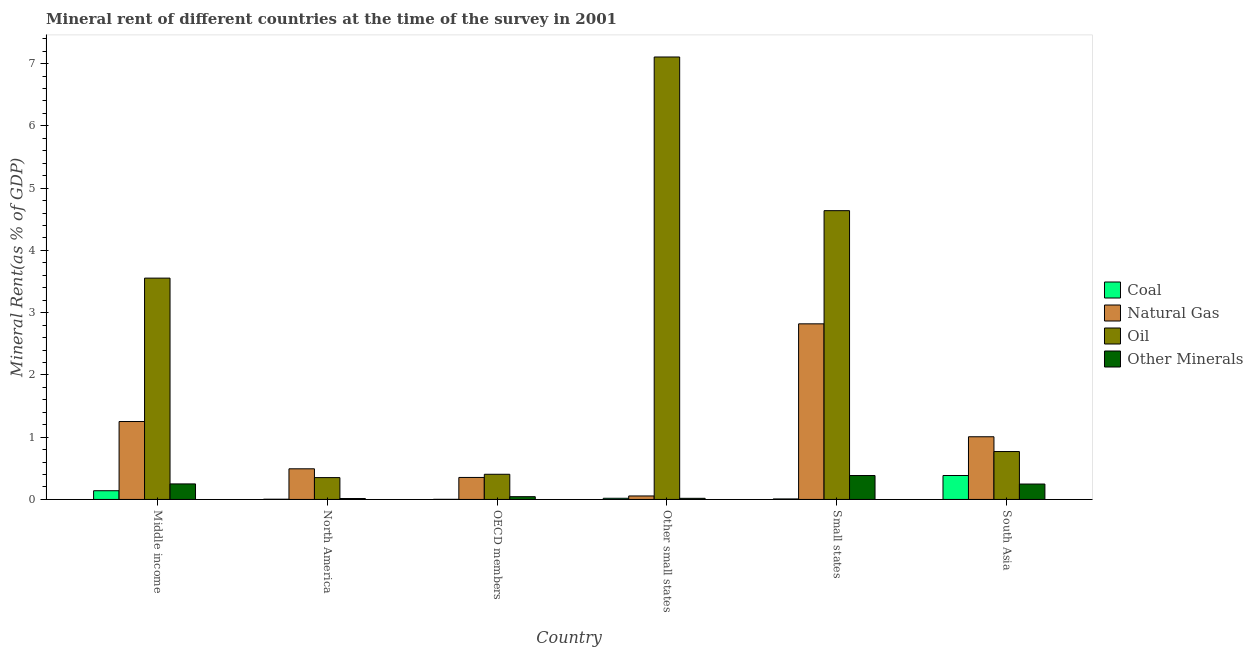How many different coloured bars are there?
Offer a very short reply. 4. How many groups of bars are there?
Ensure brevity in your answer.  6. How many bars are there on the 4th tick from the left?
Offer a very short reply. 4. What is the label of the 4th group of bars from the left?
Ensure brevity in your answer.  Other small states. In how many cases, is the number of bars for a given country not equal to the number of legend labels?
Your response must be concise. 0. What is the oil rent in North America?
Offer a terse response. 0.35. Across all countries, what is the maximum coal rent?
Offer a terse response. 0.38. Across all countries, what is the minimum coal rent?
Your answer should be very brief. 0. In which country was the  rent of other minerals maximum?
Make the answer very short. Small states. In which country was the coal rent minimum?
Provide a short and direct response. OECD members. What is the total coal rent in the graph?
Make the answer very short. 0.56. What is the difference between the  rent of other minerals in North America and that in South Asia?
Provide a short and direct response. -0.23. What is the difference between the natural gas rent in Middle income and the coal rent in North America?
Offer a terse response. 1.25. What is the average  rent of other minerals per country?
Ensure brevity in your answer.  0.16. What is the difference between the oil rent and natural gas rent in Small states?
Your response must be concise. 1.82. In how many countries, is the natural gas rent greater than 5.4 %?
Provide a succinct answer. 0. What is the ratio of the oil rent in Middle income to that in South Asia?
Offer a terse response. 4.62. Is the oil rent in Middle income less than that in Small states?
Provide a short and direct response. Yes. Is the difference between the  rent of other minerals in Middle income and South Asia greater than the difference between the oil rent in Middle income and South Asia?
Your response must be concise. No. What is the difference between the highest and the second highest coal rent?
Offer a terse response. 0.24. What is the difference between the highest and the lowest  rent of other minerals?
Keep it short and to the point. 0.37. What does the 1st bar from the left in OECD members represents?
Provide a short and direct response. Coal. What does the 4th bar from the right in OECD members represents?
Your answer should be compact. Coal. How many bars are there?
Make the answer very short. 24. Are all the bars in the graph horizontal?
Ensure brevity in your answer.  No. Are the values on the major ticks of Y-axis written in scientific E-notation?
Give a very brief answer. No. Does the graph contain grids?
Offer a very short reply. No. Where does the legend appear in the graph?
Provide a succinct answer. Center right. What is the title of the graph?
Give a very brief answer. Mineral rent of different countries at the time of the survey in 2001. Does "Primary" appear as one of the legend labels in the graph?
Your response must be concise. No. What is the label or title of the Y-axis?
Ensure brevity in your answer.  Mineral Rent(as % of GDP). What is the Mineral Rent(as % of GDP) of Coal in Middle income?
Your answer should be compact. 0.14. What is the Mineral Rent(as % of GDP) in Natural Gas in Middle income?
Your response must be concise. 1.25. What is the Mineral Rent(as % of GDP) in Oil in Middle income?
Keep it short and to the point. 3.55. What is the Mineral Rent(as % of GDP) in Other Minerals in Middle income?
Give a very brief answer. 0.25. What is the Mineral Rent(as % of GDP) in Coal in North America?
Offer a very short reply. 0. What is the Mineral Rent(as % of GDP) of Natural Gas in North America?
Make the answer very short. 0.49. What is the Mineral Rent(as % of GDP) of Oil in North America?
Your answer should be very brief. 0.35. What is the Mineral Rent(as % of GDP) in Other Minerals in North America?
Provide a short and direct response. 0.01. What is the Mineral Rent(as % of GDP) of Coal in OECD members?
Ensure brevity in your answer.  0. What is the Mineral Rent(as % of GDP) in Natural Gas in OECD members?
Provide a succinct answer. 0.35. What is the Mineral Rent(as % of GDP) in Oil in OECD members?
Your answer should be very brief. 0.4. What is the Mineral Rent(as % of GDP) in Other Minerals in OECD members?
Keep it short and to the point. 0.04. What is the Mineral Rent(as % of GDP) in Coal in Other small states?
Your answer should be compact. 0.02. What is the Mineral Rent(as % of GDP) in Natural Gas in Other small states?
Your answer should be compact. 0.06. What is the Mineral Rent(as % of GDP) in Oil in Other small states?
Your answer should be compact. 7.11. What is the Mineral Rent(as % of GDP) in Other Minerals in Other small states?
Your answer should be compact. 0.02. What is the Mineral Rent(as % of GDP) of Coal in Small states?
Give a very brief answer. 0.01. What is the Mineral Rent(as % of GDP) of Natural Gas in Small states?
Offer a very short reply. 2.82. What is the Mineral Rent(as % of GDP) of Oil in Small states?
Offer a terse response. 4.64. What is the Mineral Rent(as % of GDP) of Other Minerals in Small states?
Your answer should be very brief. 0.38. What is the Mineral Rent(as % of GDP) in Coal in South Asia?
Ensure brevity in your answer.  0.38. What is the Mineral Rent(as % of GDP) in Natural Gas in South Asia?
Provide a short and direct response. 1.01. What is the Mineral Rent(as % of GDP) in Oil in South Asia?
Give a very brief answer. 0.77. What is the Mineral Rent(as % of GDP) of Other Minerals in South Asia?
Your answer should be compact. 0.25. Across all countries, what is the maximum Mineral Rent(as % of GDP) of Coal?
Give a very brief answer. 0.38. Across all countries, what is the maximum Mineral Rent(as % of GDP) in Natural Gas?
Provide a succinct answer. 2.82. Across all countries, what is the maximum Mineral Rent(as % of GDP) of Oil?
Provide a short and direct response. 7.11. Across all countries, what is the maximum Mineral Rent(as % of GDP) of Other Minerals?
Ensure brevity in your answer.  0.38. Across all countries, what is the minimum Mineral Rent(as % of GDP) in Coal?
Offer a terse response. 0. Across all countries, what is the minimum Mineral Rent(as % of GDP) of Natural Gas?
Keep it short and to the point. 0.06. Across all countries, what is the minimum Mineral Rent(as % of GDP) in Oil?
Your answer should be very brief. 0.35. Across all countries, what is the minimum Mineral Rent(as % of GDP) in Other Minerals?
Your answer should be very brief. 0.01. What is the total Mineral Rent(as % of GDP) in Coal in the graph?
Offer a terse response. 0.56. What is the total Mineral Rent(as % of GDP) in Natural Gas in the graph?
Offer a terse response. 5.98. What is the total Mineral Rent(as % of GDP) in Oil in the graph?
Keep it short and to the point. 16.82. What is the total Mineral Rent(as % of GDP) of Other Minerals in the graph?
Give a very brief answer. 0.96. What is the difference between the Mineral Rent(as % of GDP) of Coal in Middle income and that in North America?
Make the answer very short. 0.14. What is the difference between the Mineral Rent(as % of GDP) of Natural Gas in Middle income and that in North America?
Provide a succinct answer. 0.76. What is the difference between the Mineral Rent(as % of GDP) in Oil in Middle income and that in North America?
Keep it short and to the point. 3.2. What is the difference between the Mineral Rent(as % of GDP) of Other Minerals in Middle income and that in North America?
Your response must be concise. 0.23. What is the difference between the Mineral Rent(as % of GDP) of Coal in Middle income and that in OECD members?
Keep it short and to the point. 0.14. What is the difference between the Mineral Rent(as % of GDP) in Natural Gas in Middle income and that in OECD members?
Provide a short and direct response. 0.9. What is the difference between the Mineral Rent(as % of GDP) in Oil in Middle income and that in OECD members?
Your response must be concise. 3.15. What is the difference between the Mineral Rent(as % of GDP) of Other Minerals in Middle income and that in OECD members?
Keep it short and to the point. 0.21. What is the difference between the Mineral Rent(as % of GDP) of Coal in Middle income and that in Other small states?
Provide a short and direct response. 0.12. What is the difference between the Mineral Rent(as % of GDP) of Natural Gas in Middle income and that in Other small states?
Provide a succinct answer. 1.2. What is the difference between the Mineral Rent(as % of GDP) in Oil in Middle income and that in Other small states?
Provide a succinct answer. -3.55. What is the difference between the Mineral Rent(as % of GDP) in Other Minerals in Middle income and that in Other small states?
Make the answer very short. 0.23. What is the difference between the Mineral Rent(as % of GDP) of Coal in Middle income and that in Small states?
Provide a short and direct response. 0.13. What is the difference between the Mineral Rent(as % of GDP) in Natural Gas in Middle income and that in Small states?
Keep it short and to the point. -1.57. What is the difference between the Mineral Rent(as % of GDP) of Oil in Middle income and that in Small states?
Ensure brevity in your answer.  -1.08. What is the difference between the Mineral Rent(as % of GDP) in Other Minerals in Middle income and that in Small states?
Ensure brevity in your answer.  -0.13. What is the difference between the Mineral Rent(as % of GDP) of Coal in Middle income and that in South Asia?
Ensure brevity in your answer.  -0.24. What is the difference between the Mineral Rent(as % of GDP) in Natural Gas in Middle income and that in South Asia?
Offer a very short reply. 0.24. What is the difference between the Mineral Rent(as % of GDP) of Oil in Middle income and that in South Asia?
Your answer should be compact. 2.79. What is the difference between the Mineral Rent(as % of GDP) in Other Minerals in Middle income and that in South Asia?
Your answer should be very brief. 0. What is the difference between the Mineral Rent(as % of GDP) of Coal in North America and that in OECD members?
Make the answer very short. 0. What is the difference between the Mineral Rent(as % of GDP) in Natural Gas in North America and that in OECD members?
Give a very brief answer. 0.14. What is the difference between the Mineral Rent(as % of GDP) of Oil in North America and that in OECD members?
Your answer should be compact. -0.05. What is the difference between the Mineral Rent(as % of GDP) of Other Minerals in North America and that in OECD members?
Your response must be concise. -0.03. What is the difference between the Mineral Rent(as % of GDP) in Coal in North America and that in Other small states?
Your answer should be compact. -0.02. What is the difference between the Mineral Rent(as % of GDP) of Natural Gas in North America and that in Other small states?
Provide a short and direct response. 0.44. What is the difference between the Mineral Rent(as % of GDP) in Oil in North America and that in Other small states?
Make the answer very short. -6.75. What is the difference between the Mineral Rent(as % of GDP) of Other Minerals in North America and that in Other small states?
Give a very brief answer. -0. What is the difference between the Mineral Rent(as % of GDP) in Coal in North America and that in Small states?
Provide a succinct answer. -0. What is the difference between the Mineral Rent(as % of GDP) in Natural Gas in North America and that in Small states?
Your answer should be very brief. -2.33. What is the difference between the Mineral Rent(as % of GDP) in Oil in North America and that in Small states?
Keep it short and to the point. -4.29. What is the difference between the Mineral Rent(as % of GDP) of Other Minerals in North America and that in Small states?
Your answer should be compact. -0.37. What is the difference between the Mineral Rent(as % of GDP) in Coal in North America and that in South Asia?
Provide a succinct answer. -0.38. What is the difference between the Mineral Rent(as % of GDP) of Natural Gas in North America and that in South Asia?
Your response must be concise. -0.51. What is the difference between the Mineral Rent(as % of GDP) in Oil in North America and that in South Asia?
Keep it short and to the point. -0.42. What is the difference between the Mineral Rent(as % of GDP) of Other Minerals in North America and that in South Asia?
Ensure brevity in your answer.  -0.23. What is the difference between the Mineral Rent(as % of GDP) of Coal in OECD members and that in Other small states?
Offer a terse response. -0.02. What is the difference between the Mineral Rent(as % of GDP) of Natural Gas in OECD members and that in Other small states?
Ensure brevity in your answer.  0.3. What is the difference between the Mineral Rent(as % of GDP) in Oil in OECD members and that in Other small states?
Give a very brief answer. -6.7. What is the difference between the Mineral Rent(as % of GDP) in Other Minerals in OECD members and that in Other small states?
Offer a very short reply. 0.03. What is the difference between the Mineral Rent(as % of GDP) in Coal in OECD members and that in Small states?
Provide a short and direct response. -0.01. What is the difference between the Mineral Rent(as % of GDP) in Natural Gas in OECD members and that in Small states?
Give a very brief answer. -2.47. What is the difference between the Mineral Rent(as % of GDP) of Oil in OECD members and that in Small states?
Provide a short and direct response. -4.23. What is the difference between the Mineral Rent(as % of GDP) in Other Minerals in OECD members and that in Small states?
Your answer should be compact. -0.34. What is the difference between the Mineral Rent(as % of GDP) of Coal in OECD members and that in South Asia?
Offer a terse response. -0.38. What is the difference between the Mineral Rent(as % of GDP) in Natural Gas in OECD members and that in South Asia?
Provide a succinct answer. -0.65. What is the difference between the Mineral Rent(as % of GDP) of Oil in OECD members and that in South Asia?
Offer a terse response. -0.37. What is the difference between the Mineral Rent(as % of GDP) of Other Minerals in OECD members and that in South Asia?
Ensure brevity in your answer.  -0.2. What is the difference between the Mineral Rent(as % of GDP) of Coal in Other small states and that in Small states?
Offer a terse response. 0.01. What is the difference between the Mineral Rent(as % of GDP) of Natural Gas in Other small states and that in Small states?
Ensure brevity in your answer.  -2.76. What is the difference between the Mineral Rent(as % of GDP) in Oil in Other small states and that in Small states?
Your answer should be very brief. 2.47. What is the difference between the Mineral Rent(as % of GDP) of Other Minerals in Other small states and that in Small states?
Provide a short and direct response. -0.37. What is the difference between the Mineral Rent(as % of GDP) of Coal in Other small states and that in South Asia?
Your response must be concise. -0.37. What is the difference between the Mineral Rent(as % of GDP) of Natural Gas in Other small states and that in South Asia?
Make the answer very short. -0.95. What is the difference between the Mineral Rent(as % of GDP) of Oil in Other small states and that in South Asia?
Make the answer very short. 6.34. What is the difference between the Mineral Rent(as % of GDP) in Other Minerals in Other small states and that in South Asia?
Offer a terse response. -0.23. What is the difference between the Mineral Rent(as % of GDP) in Coal in Small states and that in South Asia?
Provide a succinct answer. -0.38. What is the difference between the Mineral Rent(as % of GDP) in Natural Gas in Small states and that in South Asia?
Make the answer very short. 1.81. What is the difference between the Mineral Rent(as % of GDP) of Oil in Small states and that in South Asia?
Offer a terse response. 3.87. What is the difference between the Mineral Rent(as % of GDP) of Other Minerals in Small states and that in South Asia?
Offer a very short reply. 0.14. What is the difference between the Mineral Rent(as % of GDP) in Coal in Middle income and the Mineral Rent(as % of GDP) in Natural Gas in North America?
Offer a very short reply. -0.35. What is the difference between the Mineral Rent(as % of GDP) of Coal in Middle income and the Mineral Rent(as % of GDP) of Oil in North America?
Provide a short and direct response. -0.21. What is the difference between the Mineral Rent(as % of GDP) of Coal in Middle income and the Mineral Rent(as % of GDP) of Other Minerals in North America?
Give a very brief answer. 0.13. What is the difference between the Mineral Rent(as % of GDP) in Natural Gas in Middle income and the Mineral Rent(as % of GDP) in Oil in North America?
Your response must be concise. 0.9. What is the difference between the Mineral Rent(as % of GDP) in Natural Gas in Middle income and the Mineral Rent(as % of GDP) in Other Minerals in North America?
Keep it short and to the point. 1.24. What is the difference between the Mineral Rent(as % of GDP) of Oil in Middle income and the Mineral Rent(as % of GDP) of Other Minerals in North America?
Offer a terse response. 3.54. What is the difference between the Mineral Rent(as % of GDP) in Coal in Middle income and the Mineral Rent(as % of GDP) in Natural Gas in OECD members?
Offer a terse response. -0.21. What is the difference between the Mineral Rent(as % of GDP) in Coal in Middle income and the Mineral Rent(as % of GDP) in Oil in OECD members?
Your answer should be compact. -0.26. What is the difference between the Mineral Rent(as % of GDP) in Coal in Middle income and the Mineral Rent(as % of GDP) in Other Minerals in OECD members?
Make the answer very short. 0.1. What is the difference between the Mineral Rent(as % of GDP) in Natural Gas in Middle income and the Mineral Rent(as % of GDP) in Oil in OECD members?
Your answer should be compact. 0.85. What is the difference between the Mineral Rent(as % of GDP) of Natural Gas in Middle income and the Mineral Rent(as % of GDP) of Other Minerals in OECD members?
Provide a succinct answer. 1.21. What is the difference between the Mineral Rent(as % of GDP) of Oil in Middle income and the Mineral Rent(as % of GDP) of Other Minerals in OECD members?
Your answer should be compact. 3.51. What is the difference between the Mineral Rent(as % of GDP) of Coal in Middle income and the Mineral Rent(as % of GDP) of Natural Gas in Other small states?
Offer a very short reply. 0.08. What is the difference between the Mineral Rent(as % of GDP) in Coal in Middle income and the Mineral Rent(as % of GDP) in Oil in Other small states?
Your response must be concise. -6.97. What is the difference between the Mineral Rent(as % of GDP) of Coal in Middle income and the Mineral Rent(as % of GDP) of Other Minerals in Other small states?
Provide a short and direct response. 0.12. What is the difference between the Mineral Rent(as % of GDP) in Natural Gas in Middle income and the Mineral Rent(as % of GDP) in Oil in Other small states?
Make the answer very short. -5.85. What is the difference between the Mineral Rent(as % of GDP) in Natural Gas in Middle income and the Mineral Rent(as % of GDP) in Other Minerals in Other small states?
Your response must be concise. 1.23. What is the difference between the Mineral Rent(as % of GDP) of Oil in Middle income and the Mineral Rent(as % of GDP) of Other Minerals in Other small states?
Keep it short and to the point. 3.54. What is the difference between the Mineral Rent(as % of GDP) of Coal in Middle income and the Mineral Rent(as % of GDP) of Natural Gas in Small states?
Keep it short and to the point. -2.68. What is the difference between the Mineral Rent(as % of GDP) of Coal in Middle income and the Mineral Rent(as % of GDP) of Oil in Small states?
Provide a short and direct response. -4.5. What is the difference between the Mineral Rent(as % of GDP) in Coal in Middle income and the Mineral Rent(as % of GDP) in Other Minerals in Small states?
Make the answer very short. -0.24. What is the difference between the Mineral Rent(as % of GDP) of Natural Gas in Middle income and the Mineral Rent(as % of GDP) of Oil in Small states?
Your answer should be very brief. -3.39. What is the difference between the Mineral Rent(as % of GDP) of Natural Gas in Middle income and the Mineral Rent(as % of GDP) of Other Minerals in Small states?
Provide a short and direct response. 0.87. What is the difference between the Mineral Rent(as % of GDP) of Oil in Middle income and the Mineral Rent(as % of GDP) of Other Minerals in Small states?
Keep it short and to the point. 3.17. What is the difference between the Mineral Rent(as % of GDP) of Coal in Middle income and the Mineral Rent(as % of GDP) of Natural Gas in South Asia?
Offer a terse response. -0.87. What is the difference between the Mineral Rent(as % of GDP) in Coal in Middle income and the Mineral Rent(as % of GDP) in Oil in South Asia?
Keep it short and to the point. -0.63. What is the difference between the Mineral Rent(as % of GDP) in Coal in Middle income and the Mineral Rent(as % of GDP) in Other Minerals in South Asia?
Your answer should be compact. -0.11. What is the difference between the Mineral Rent(as % of GDP) of Natural Gas in Middle income and the Mineral Rent(as % of GDP) of Oil in South Asia?
Give a very brief answer. 0.48. What is the difference between the Mineral Rent(as % of GDP) in Natural Gas in Middle income and the Mineral Rent(as % of GDP) in Other Minerals in South Asia?
Make the answer very short. 1. What is the difference between the Mineral Rent(as % of GDP) in Oil in Middle income and the Mineral Rent(as % of GDP) in Other Minerals in South Asia?
Your answer should be very brief. 3.31. What is the difference between the Mineral Rent(as % of GDP) in Coal in North America and the Mineral Rent(as % of GDP) in Natural Gas in OECD members?
Provide a short and direct response. -0.35. What is the difference between the Mineral Rent(as % of GDP) in Coal in North America and the Mineral Rent(as % of GDP) in Oil in OECD members?
Make the answer very short. -0.4. What is the difference between the Mineral Rent(as % of GDP) in Coal in North America and the Mineral Rent(as % of GDP) in Other Minerals in OECD members?
Your answer should be very brief. -0.04. What is the difference between the Mineral Rent(as % of GDP) of Natural Gas in North America and the Mineral Rent(as % of GDP) of Oil in OECD members?
Give a very brief answer. 0.09. What is the difference between the Mineral Rent(as % of GDP) in Natural Gas in North America and the Mineral Rent(as % of GDP) in Other Minerals in OECD members?
Give a very brief answer. 0.45. What is the difference between the Mineral Rent(as % of GDP) in Oil in North America and the Mineral Rent(as % of GDP) in Other Minerals in OECD members?
Offer a terse response. 0.31. What is the difference between the Mineral Rent(as % of GDP) in Coal in North America and the Mineral Rent(as % of GDP) in Natural Gas in Other small states?
Give a very brief answer. -0.05. What is the difference between the Mineral Rent(as % of GDP) of Coal in North America and the Mineral Rent(as % of GDP) of Oil in Other small states?
Ensure brevity in your answer.  -7.1. What is the difference between the Mineral Rent(as % of GDP) in Coal in North America and the Mineral Rent(as % of GDP) in Other Minerals in Other small states?
Keep it short and to the point. -0.01. What is the difference between the Mineral Rent(as % of GDP) in Natural Gas in North America and the Mineral Rent(as % of GDP) in Oil in Other small states?
Provide a succinct answer. -6.61. What is the difference between the Mineral Rent(as % of GDP) in Natural Gas in North America and the Mineral Rent(as % of GDP) in Other Minerals in Other small states?
Your answer should be very brief. 0.47. What is the difference between the Mineral Rent(as % of GDP) in Oil in North America and the Mineral Rent(as % of GDP) in Other Minerals in Other small states?
Offer a very short reply. 0.33. What is the difference between the Mineral Rent(as % of GDP) of Coal in North America and the Mineral Rent(as % of GDP) of Natural Gas in Small states?
Offer a very short reply. -2.82. What is the difference between the Mineral Rent(as % of GDP) in Coal in North America and the Mineral Rent(as % of GDP) in Oil in Small states?
Give a very brief answer. -4.63. What is the difference between the Mineral Rent(as % of GDP) of Coal in North America and the Mineral Rent(as % of GDP) of Other Minerals in Small states?
Offer a very short reply. -0.38. What is the difference between the Mineral Rent(as % of GDP) in Natural Gas in North America and the Mineral Rent(as % of GDP) in Oil in Small states?
Ensure brevity in your answer.  -4.15. What is the difference between the Mineral Rent(as % of GDP) in Natural Gas in North America and the Mineral Rent(as % of GDP) in Other Minerals in Small states?
Your answer should be compact. 0.11. What is the difference between the Mineral Rent(as % of GDP) in Oil in North America and the Mineral Rent(as % of GDP) in Other Minerals in Small states?
Offer a very short reply. -0.03. What is the difference between the Mineral Rent(as % of GDP) of Coal in North America and the Mineral Rent(as % of GDP) of Natural Gas in South Asia?
Provide a short and direct response. -1. What is the difference between the Mineral Rent(as % of GDP) of Coal in North America and the Mineral Rent(as % of GDP) of Oil in South Asia?
Make the answer very short. -0.77. What is the difference between the Mineral Rent(as % of GDP) in Coal in North America and the Mineral Rent(as % of GDP) in Other Minerals in South Asia?
Give a very brief answer. -0.24. What is the difference between the Mineral Rent(as % of GDP) in Natural Gas in North America and the Mineral Rent(as % of GDP) in Oil in South Asia?
Offer a very short reply. -0.28. What is the difference between the Mineral Rent(as % of GDP) in Natural Gas in North America and the Mineral Rent(as % of GDP) in Other Minerals in South Asia?
Provide a succinct answer. 0.24. What is the difference between the Mineral Rent(as % of GDP) in Oil in North America and the Mineral Rent(as % of GDP) in Other Minerals in South Asia?
Make the answer very short. 0.1. What is the difference between the Mineral Rent(as % of GDP) of Coal in OECD members and the Mineral Rent(as % of GDP) of Natural Gas in Other small states?
Offer a terse response. -0.05. What is the difference between the Mineral Rent(as % of GDP) of Coal in OECD members and the Mineral Rent(as % of GDP) of Oil in Other small states?
Offer a very short reply. -7.1. What is the difference between the Mineral Rent(as % of GDP) of Coal in OECD members and the Mineral Rent(as % of GDP) of Other Minerals in Other small states?
Offer a terse response. -0.02. What is the difference between the Mineral Rent(as % of GDP) in Natural Gas in OECD members and the Mineral Rent(as % of GDP) in Oil in Other small states?
Give a very brief answer. -6.75. What is the difference between the Mineral Rent(as % of GDP) of Natural Gas in OECD members and the Mineral Rent(as % of GDP) of Other Minerals in Other small states?
Your answer should be compact. 0.34. What is the difference between the Mineral Rent(as % of GDP) of Oil in OECD members and the Mineral Rent(as % of GDP) of Other Minerals in Other small states?
Ensure brevity in your answer.  0.39. What is the difference between the Mineral Rent(as % of GDP) of Coal in OECD members and the Mineral Rent(as % of GDP) of Natural Gas in Small states?
Offer a very short reply. -2.82. What is the difference between the Mineral Rent(as % of GDP) in Coal in OECD members and the Mineral Rent(as % of GDP) in Oil in Small states?
Your answer should be compact. -4.64. What is the difference between the Mineral Rent(as % of GDP) of Coal in OECD members and the Mineral Rent(as % of GDP) of Other Minerals in Small states?
Offer a terse response. -0.38. What is the difference between the Mineral Rent(as % of GDP) in Natural Gas in OECD members and the Mineral Rent(as % of GDP) in Oil in Small states?
Offer a very short reply. -4.28. What is the difference between the Mineral Rent(as % of GDP) of Natural Gas in OECD members and the Mineral Rent(as % of GDP) of Other Minerals in Small states?
Make the answer very short. -0.03. What is the difference between the Mineral Rent(as % of GDP) of Oil in OECD members and the Mineral Rent(as % of GDP) of Other Minerals in Small states?
Keep it short and to the point. 0.02. What is the difference between the Mineral Rent(as % of GDP) in Coal in OECD members and the Mineral Rent(as % of GDP) in Natural Gas in South Asia?
Your answer should be very brief. -1. What is the difference between the Mineral Rent(as % of GDP) of Coal in OECD members and the Mineral Rent(as % of GDP) of Oil in South Asia?
Give a very brief answer. -0.77. What is the difference between the Mineral Rent(as % of GDP) in Coal in OECD members and the Mineral Rent(as % of GDP) in Other Minerals in South Asia?
Offer a very short reply. -0.25. What is the difference between the Mineral Rent(as % of GDP) in Natural Gas in OECD members and the Mineral Rent(as % of GDP) in Oil in South Asia?
Your answer should be very brief. -0.42. What is the difference between the Mineral Rent(as % of GDP) of Natural Gas in OECD members and the Mineral Rent(as % of GDP) of Other Minerals in South Asia?
Give a very brief answer. 0.11. What is the difference between the Mineral Rent(as % of GDP) of Oil in OECD members and the Mineral Rent(as % of GDP) of Other Minerals in South Asia?
Your answer should be compact. 0.16. What is the difference between the Mineral Rent(as % of GDP) in Coal in Other small states and the Mineral Rent(as % of GDP) in Natural Gas in Small states?
Keep it short and to the point. -2.8. What is the difference between the Mineral Rent(as % of GDP) of Coal in Other small states and the Mineral Rent(as % of GDP) of Oil in Small states?
Keep it short and to the point. -4.62. What is the difference between the Mineral Rent(as % of GDP) of Coal in Other small states and the Mineral Rent(as % of GDP) of Other Minerals in Small states?
Keep it short and to the point. -0.37. What is the difference between the Mineral Rent(as % of GDP) of Natural Gas in Other small states and the Mineral Rent(as % of GDP) of Oil in Small states?
Provide a succinct answer. -4.58. What is the difference between the Mineral Rent(as % of GDP) of Natural Gas in Other small states and the Mineral Rent(as % of GDP) of Other Minerals in Small states?
Give a very brief answer. -0.33. What is the difference between the Mineral Rent(as % of GDP) of Oil in Other small states and the Mineral Rent(as % of GDP) of Other Minerals in Small states?
Provide a short and direct response. 6.72. What is the difference between the Mineral Rent(as % of GDP) of Coal in Other small states and the Mineral Rent(as % of GDP) of Natural Gas in South Asia?
Offer a very short reply. -0.99. What is the difference between the Mineral Rent(as % of GDP) of Coal in Other small states and the Mineral Rent(as % of GDP) of Oil in South Asia?
Your answer should be compact. -0.75. What is the difference between the Mineral Rent(as % of GDP) in Coal in Other small states and the Mineral Rent(as % of GDP) in Other Minerals in South Asia?
Provide a succinct answer. -0.23. What is the difference between the Mineral Rent(as % of GDP) of Natural Gas in Other small states and the Mineral Rent(as % of GDP) of Oil in South Asia?
Your answer should be very brief. -0.71. What is the difference between the Mineral Rent(as % of GDP) of Natural Gas in Other small states and the Mineral Rent(as % of GDP) of Other Minerals in South Asia?
Make the answer very short. -0.19. What is the difference between the Mineral Rent(as % of GDP) in Oil in Other small states and the Mineral Rent(as % of GDP) in Other Minerals in South Asia?
Your answer should be very brief. 6.86. What is the difference between the Mineral Rent(as % of GDP) in Coal in Small states and the Mineral Rent(as % of GDP) in Natural Gas in South Asia?
Make the answer very short. -1. What is the difference between the Mineral Rent(as % of GDP) of Coal in Small states and the Mineral Rent(as % of GDP) of Oil in South Asia?
Your response must be concise. -0.76. What is the difference between the Mineral Rent(as % of GDP) in Coal in Small states and the Mineral Rent(as % of GDP) in Other Minerals in South Asia?
Make the answer very short. -0.24. What is the difference between the Mineral Rent(as % of GDP) of Natural Gas in Small states and the Mineral Rent(as % of GDP) of Oil in South Asia?
Your response must be concise. 2.05. What is the difference between the Mineral Rent(as % of GDP) of Natural Gas in Small states and the Mineral Rent(as % of GDP) of Other Minerals in South Asia?
Provide a succinct answer. 2.57. What is the difference between the Mineral Rent(as % of GDP) in Oil in Small states and the Mineral Rent(as % of GDP) in Other Minerals in South Asia?
Your response must be concise. 4.39. What is the average Mineral Rent(as % of GDP) of Coal per country?
Provide a succinct answer. 0.09. What is the average Mineral Rent(as % of GDP) in Natural Gas per country?
Your answer should be compact. 1. What is the average Mineral Rent(as % of GDP) in Oil per country?
Your answer should be compact. 2.8. What is the average Mineral Rent(as % of GDP) of Other Minerals per country?
Keep it short and to the point. 0.16. What is the difference between the Mineral Rent(as % of GDP) of Coal and Mineral Rent(as % of GDP) of Natural Gas in Middle income?
Keep it short and to the point. -1.11. What is the difference between the Mineral Rent(as % of GDP) of Coal and Mineral Rent(as % of GDP) of Oil in Middle income?
Your response must be concise. -3.41. What is the difference between the Mineral Rent(as % of GDP) in Coal and Mineral Rent(as % of GDP) in Other Minerals in Middle income?
Give a very brief answer. -0.11. What is the difference between the Mineral Rent(as % of GDP) in Natural Gas and Mineral Rent(as % of GDP) in Oil in Middle income?
Your answer should be very brief. -2.3. What is the difference between the Mineral Rent(as % of GDP) in Natural Gas and Mineral Rent(as % of GDP) in Other Minerals in Middle income?
Ensure brevity in your answer.  1. What is the difference between the Mineral Rent(as % of GDP) in Oil and Mineral Rent(as % of GDP) in Other Minerals in Middle income?
Keep it short and to the point. 3.31. What is the difference between the Mineral Rent(as % of GDP) in Coal and Mineral Rent(as % of GDP) in Natural Gas in North America?
Give a very brief answer. -0.49. What is the difference between the Mineral Rent(as % of GDP) of Coal and Mineral Rent(as % of GDP) of Oil in North America?
Provide a succinct answer. -0.35. What is the difference between the Mineral Rent(as % of GDP) in Coal and Mineral Rent(as % of GDP) in Other Minerals in North America?
Your response must be concise. -0.01. What is the difference between the Mineral Rent(as % of GDP) in Natural Gas and Mineral Rent(as % of GDP) in Oil in North America?
Ensure brevity in your answer.  0.14. What is the difference between the Mineral Rent(as % of GDP) of Natural Gas and Mineral Rent(as % of GDP) of Other Minerals in North America?
Make the answer very short. 0.48. What is the difference between the Mineral Rent(as % of GDP) of Oil and Mineral Rent(as % of GDP) of Other Minerals in North America?
Ensure brevity in your answer.  0.34. What is the difference between the Mineral Rent(as % of GDP) in Coal and Mineral Rent(as % of GDP) in Natural Gas in OECD members?
Your answer should be compact. -0.35. What is the difference between the Mineral Rent(as % of GDP) of Coal and Mineral Rent(as % of GDP) of Oil in OECD members?
Give a very brief answer. -0.4. What is the difference between the Mineral Rent(as % of GDP) of Coal and Mineral Rent(as % of GDP) of Other Minerals in OECD members?
Ensure brevity in your answer.  -0.04. What is the difference between the Mineral Rent(as % of GDP) in Natural Gas and Mineral Rent(as % of GDP) in Oil in OECD members?
Your answer should be very brief. -0.05. What is the difference between the Mineral Rent(as % of GDP) in Natural Gas and Mineral Rent(as % of GDP) in Other Minerals in OECD members?
Provide a short and direct response. 0.31. What is the difference between the Mineral Rent(as % of GDP) in Oil and Mineral Rent(as % of GDP) in Other Minerals in OECD members?
Ensure brevity in your answer.  0.36. What is the difference between the Mineral Rent(as % of GDP) in Coal and Mineral Rent(as % of GDP) in Natural Gas in Other small states?
Give a very brief answer. -0.04. What is the difference between the Mineral Rent(as % of GDP) in Coal and Mineral Rent(as % of GDP) in Oil in Other small states?
Provide a succinct answer. -7.09. What is the difference between the Mineral Rent(as % of GDP) of Coal and Mineral Rent(as % of GDP) of Other Minerals in Other small states?
Ensure brevity in your answer.  0. What is the difference between the Mineral Rent(as % of GDP) in Natural Gas and Mineral Rent(as % of GDP) in Oil in Other small states?
Keep it short and to the point. -7.05. What is the difference between the Mineral Rent(as % of GDP) in Natural Gas and Mineral Rent(as % of GDP) in Other Minerals in Other small states?
Keep it short and to the point. 0.04. What is the difference between the Mineral Rent(as % of GDP) in Oil and Mineral Rent(as % of GDP) in Other Minerals in Other small states?
Provide a succinct answer. 7.09. What is the difference between the Mineral Rent(as % of GDP) of Coal and Mineral Rent(as % of GDP) of Natural Gas in Small states?
Ensure brevity in your answer.  -2.81. What is the difference between the Mineral Rent(as % of GDP) of Coal and Mineral Rent(as % of GDP) of Oil in Small states?
Your answer should be compact. -4.63. What is the difference between the Mineral Rent(as % of GDP) of Coal and Mineral Rent(as % of GDP) of Other Minerals in Small states?
Your answer should be compact. -0.38. What is the difference between the Mineral Rent(as % of GDP) in Natural Gas and Mineral Rent(as % of GDP) in Oil in Small states?
Provide a succinct answer. -1.82. What is the difference between the Mineral Rent(as % of GDP) in Natural Gas and Mineral Rent(as % of GDP) in Other Minerals in Small states?
Keep it short and to the point. 2.44. What is the difference between the Mineral Rent(as % of GDP) in Oil and Mineral Rent(as % of GDP) in Other Minerals in Small states?
Your answer should be very brief. 4.25. What is the difference between the Mineral Rent(as % of GDP) of Coal and Mineral Rent(as % of GDP) of Natural Gas in South Asia?
Provide a succinct answer. -0.62. What is the difference between the Mineral Rent(as % of GDP) of Coal and Mineral Rent(as % of GDP) of Oil in South Asia?
Give a very brief answer. -0.39. What is the difference between the Mineral Rent(as % of GDP) of Coal and Mineral Rent(as % of GDP) of Other Minerals in South Asia?
Provide a succinct answer. 0.14. What is the difference between the Mineral Rent(as % of GDP) of Natural Gas and Mineral Rent(as % of GDP) of Oil in South Asia?
Your answer should be very brief. 0.24. What is the difference between the Mineral Rent(as % of GDP) in Natural Gas and Mineral Rent(as % of GDP) in Other Minerals in South Asia?
Your answer should be very brief. 0.76. What is the difference between the Mineral Rent(as % of GDP) of Oil and Mineral Rent(as % of GDP) of Other Minerals in South Asia?
Make the answer very short. 0.52. What is the ratio of the Mineral Rent(as % of GDP) in Coal in Middle income to that in North America?
Your answer should be compact. 39.48. What is the ratio of the Mineral Rent(as % of GDP) in Natural Gas in Middle income to that in North America?
Give a very brief answer. 2.54. What is the ratio of the Mineral Rent(as % of GDP) in Oil in Middle income to that in North America?
Provide a short and direct response. 10.13. What is the ratio of the Mineral Rent(as % of GDP) of Other Minerals in Middle income to that in North America?
Make the answer very short. 16.85. What is the ratio of the Mineral Rent(as % of GDP) of Coal in Middle income to that in OECD members?
Your answer should be very brief. 78.06. What is the ratio of the Mineral Rent(as % of GDP) in Natural Gas in Middle income to that in OECD members?
Your response must be concise. 3.54. What is the ratio of the Mineral Rent(as % of GDP) in Oil in Middle income to that in OECD members?
Give a very brief answer. 8.79. What is the ratio of the Mineral Rent(as % of GDP) in Other Minerals in Middle income to that in OECD members?
Give a very brief answer. 5.62. What is the ratio of the Mineral Rent(as % of GDP) in Coal in Middle income to that in Other small states?
Make the answer very short. 7.38. What is the ratio of the Mineral Rent(as % of GDP) in Natural Gas in Middle income to that in Other small states?
Offer a terse response. 22.27. What is the ratio of the Mineral Rent(as % of GDP) in Oil in Middle income to that in Other small states?
Give a very brief answer. 0.5. What is the ratio of the Mineral Rent(as % of GDP) of Other Minerals in Middle income to that in Other small states?
Give a very brief answer. 13.74. What is the ratio of the Mineral Rent(as % of GDP) of Coal in Middle income to that in Small states?
Give a very brief answer. 17.45. What is the ratio of the Mineral Rent(as % of GDP) of Natural Gas in Middle income to that in Small states?
Keep it short and to the point. 0.44. What is the ratio of the Mineral Rent(as % of GDP) in Oil in Middle income to that in Small states?
Make the answer very short. 0.77. What is the ratio of the Mineral Rent(as % of GDP) of Other Minerals in Middle income to that in Small states?
Your response must be concise. 0.65. What is the ratio of the Mineral Rent(as % of GDP) in Coal in Middle income to that in South Asia?
Give a very brief answer. 0.36. What is the ratio of the Mineral Rent(as % of GDP) in Natural Gas in Middle income to that in South Asia?
Your answer should be compact. 1.24. What is the ratio of the Mineral Rent(as % of GDP) in Oil in Middle income to that in South Asia?
Your answer should be very brief. 4.62. What is the ratio of the Mineral Rent(as % of GDP) of Other Minerals in Middle income to that in South Asia?
Offer a very short reply. 1.01. What is the ratio of the Mineral Rent(as % of GDP) in Coal in North America to that in OECD members?
Provide a succinct answer. 1.98. What is the ratio of the Mineral Rent(as % of GDP) in Natural Gas in North America to that in OECD members?
Give a very brief answer. 1.39. What is the ratio of the Mineral Rent(as % of GDP) of Oil in North America to that in OECD members?
Make the answer very short. 0.87. What is the ratio of the Mineral Rent(as % of GDP) of Other Minerals in North America to that in OECD members?
Your answer should be very brief. 0.33. What is the ratio of the Mineral Rent(as % of GDP) of Coal in North America to that in Other small states?
Offer a very short reply. 0.19. What is the ratio of the Mineral Rent(as % of GDP) in Natural Gas in North America to that in Other small states?
Ensure brevity in your answer.  8.76. What is the ratio of the Mineral Rent(as % of GDP) of Oil in North America to that in Other small states?
Offer a very short reply. 0.05. What is the ratio of the Mineral Rent(as % of GDP) in Other Minerals in North America to that in Other small states?
Keep it short and to the point. 0.82. What is the ratio of the Mineral Rent(as % of GDP) of Coal in North America to that in Small states?
Offer a very short reply. 0.44. What is the ratio of the Mineral Rent(as % of GDP) in Natural Gas in North America to that in Small states?
Offer a very short reply. 0.17. What is the ratio of the Mineral Rent(as % of GDP) in Oil in North America to that in Small states?
Your response must be concise. 0.08. What is the ratio of the Mineral Rent(as % of GDP) of Other Minerals in North America to that in Small states?
Offer a terse response. 0.04. What is the ratio of the Mineral Rent(as % of GDP) of Coal in North America to that in South Asia?
Offer a terse response. 0.01. What is the ratio of the Mineral Rent(as % of GDP) in Natural Gas in North America to that in South Asia?
Make the answer very short. 0.49. What is the ratio of the Mineral Rent(as % of GDP) in Oil in North America to that in South Asia?
Make the answer very short. 0.46. What is the ratio of the Mineral Rent(as % of GDP) of Other Minerals in North America to that in South Asia?
Provide a short and direct response. 0.06. What is the ratio of the Mineral Rent(as % of GDP) of Coal in OECD members to that in Other small states?
Make the answer very short. 0.09. What is the ratio of the Mineral Rent(as % of GDP) of Natural Gas in OECD members to that in Other small states?
Your response must be concise. 6.29. What is the ratio of the Mineral Rent(as % of GDP) in Oil in OECD members to that in Other small states?
Give a very brief answer. 0.06. What is the ratio of the Mineral Rent(as % of GDP) of Other Minerals in OECD members to that in Other small states?
Ensure brevity in your answer.  2.45. What is the ratio of the Mineral Rent(as % of GDP) in Coal in OECD members to that in Small states?
Provide a succinct answer. 0.22. What is the ratio of the Mineral Rent(as % of GDP) in Natural Gas in OECD members to that in Small states?
Your response must be concise. 0.13. What is the ratio of the Mineral Rent(as % of GDP) in Oil in OECD members to that in Small states?
Make the answer very short. 0.09. What is the ratio of the Mineral Rent(as % of GDP) in Other Minerals in OECD members to that in Small states?
Give a very brief answer. 0.12. What is the ratio of the Mineral Rent(as % of GDP) of Coal in OECD members to that in South Asia?
Provide a succinct answer. 0. What is the ratio of the Mineral Rent(as % of GDP) in Natural Gas in OECD members to that in South Asia?
Your response must be concise. 0.35. What is the ratio of the Mineral Rent(as % of GDP) in Oil in OECD members to that in South Asia?
Your answer should be compact. 0.53. What is the ratio of the Mineral Rent(as % of GDP) of Other Minerals in OECD members to that in South Asia?
Keep it short and to the point. 0.18. What is the ratio of the Mineral Rent(as % of GDP) of Coal in Other small states to that in Small states?
Ensure brevity in your answer.  2.36. What is the ratio of the Mineral Rent(as % of GDP) in Natural Gas in Other small states to that in Small states?
Make the answer very short. 0.02. What is the ratio of the Mineral Rent(as % of GDP) of Oil in Other small states to that in Small states?
Give a very brief answer. 1.53. What is the ratio of the Mineral Rent(as % of GDP) in Other Minerals in Other small states to that in Small states?
Offer a very short reply. 0.05. What is the ratio of the Mineral Rent(as % of GDP) of Coal in Other small states to that in South Asia?
Make the answer very short. 0.05. What is the ratio of the Mineral Rent(as % of GDP) in Natural Gas in Other small states to that in South Asia?
Ensure brevity in your answer.  0.06. What is the ratio of the Mineral Rent(as % of GDP) of Oil in Other small states to that in South Asia?
Ensure brevity in your answer.  9.23. What is the ratio of the Mineral Rent(as % of GDP) in Other Minerals in Other small states to that in South Asia?
Provide a succinct answer. 0.07. What is the ratio of the Mineral Rent(as % of GDP) in Coal in Small states to that in South Asia?
Offer a terse response. 0.02. What is the ratio of the Mineral Rent(as % of GDP) in Natural Gas in Small states to that in South Asia?
Provide a succinct answer. 2.8. What is the ratio of the Mineral Rent(as % of GDP) of Oil in Small states to that in South Asia?
Provide a short and direct response. 6.03. What is the ratio of the Mineral Rent(as % of GDP) in Other Minerals in Small states to that in South Asia?
Offer a terse response. 1.55. What is the difference between the highest and the second highest Mineral Rent(as % of GDP) of Coal?
Provide a short and direct response. 0.24. What is the difference between the highest and the second highest Mineral Rent(as % of GDP) of Natural Gas?
Make the answer very short. 1.57. What is the difference between the highest and the second highest Mineral Rent(as % of GDP) in Oil?
Your response must be concise. 2.47. What is the difference between the highest and the second highest Mineral Rent(as % of GDP) of Other Minerals?
Your answer should be compact. 0.13. What is the difference between the highest and the lowest Mineral Rent(as % of GDP) in Coal?
Your answer should be compact. 0.38. What is the difference between the highest and the lowest Mineral Rent(as % of GDP) in Natural Gas?
Make the answer very short. 2.76. What is the difference between the highest and the lowest Mineral Rent(as % of GDP) of Oil?
Your answer should be very brief. 6.75. What is the difference between the highest and the lowest Mineral Rent(as % of GDP) of Other Minerals?
Your answer should be compact. 0.37. 